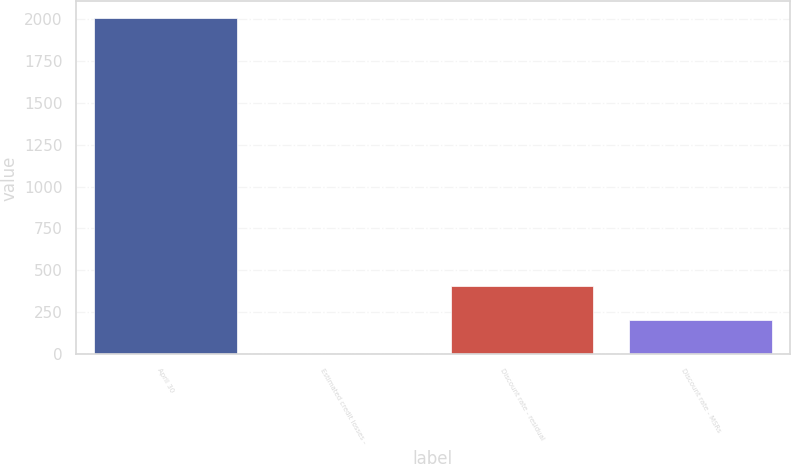Convert chart to OTSL. <chart><loc_0><loc_0><loc_500><loc_500><bar_chart><fcel>April 30<fcel>Estimated credit losses -<fcel>Discount rate - residual<fcel>Discount rate - MSRs<nl><fcel>2004<fcel>4.16<fcel>404.12<fcel>204.14<nl></chart> 